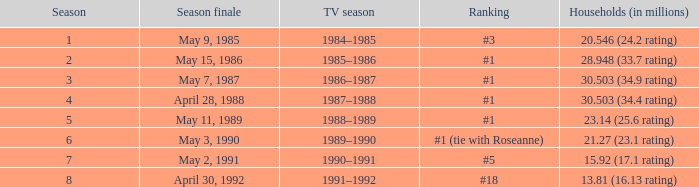Which TV season has a Season smaller than 8, and a Household (in millions) of 15.92 (17.1 rating)? 1990–1991. 